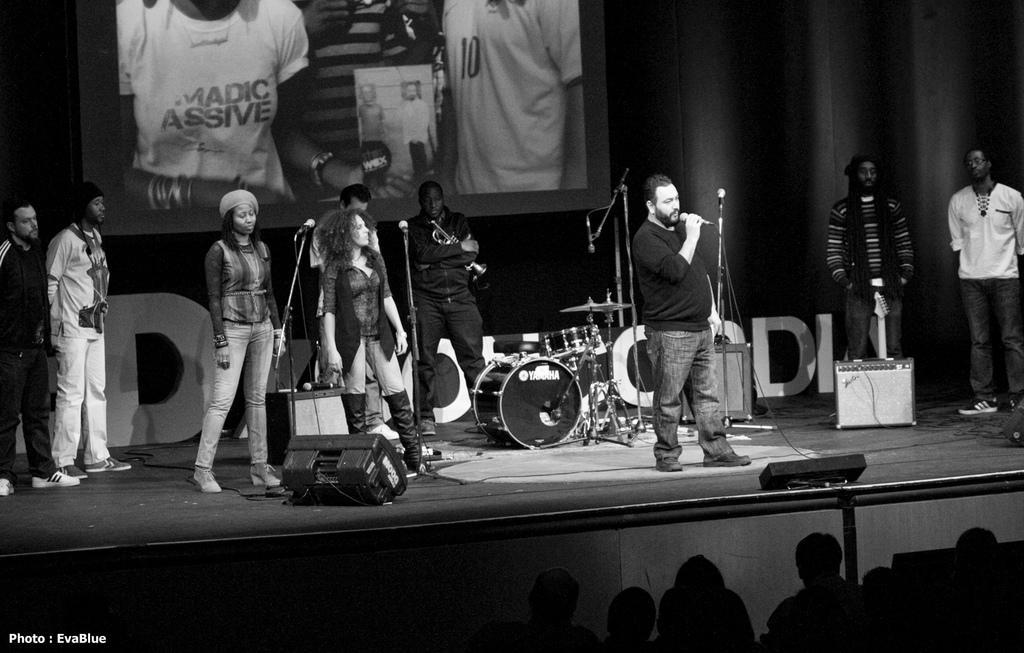In one or two sentences, can you explain what this image depicts? It is a black and white image there is some music concert being held on the stage and behind the stage there is some image is being projected on the screen and in front of the stage there are audience enjoying the music. 